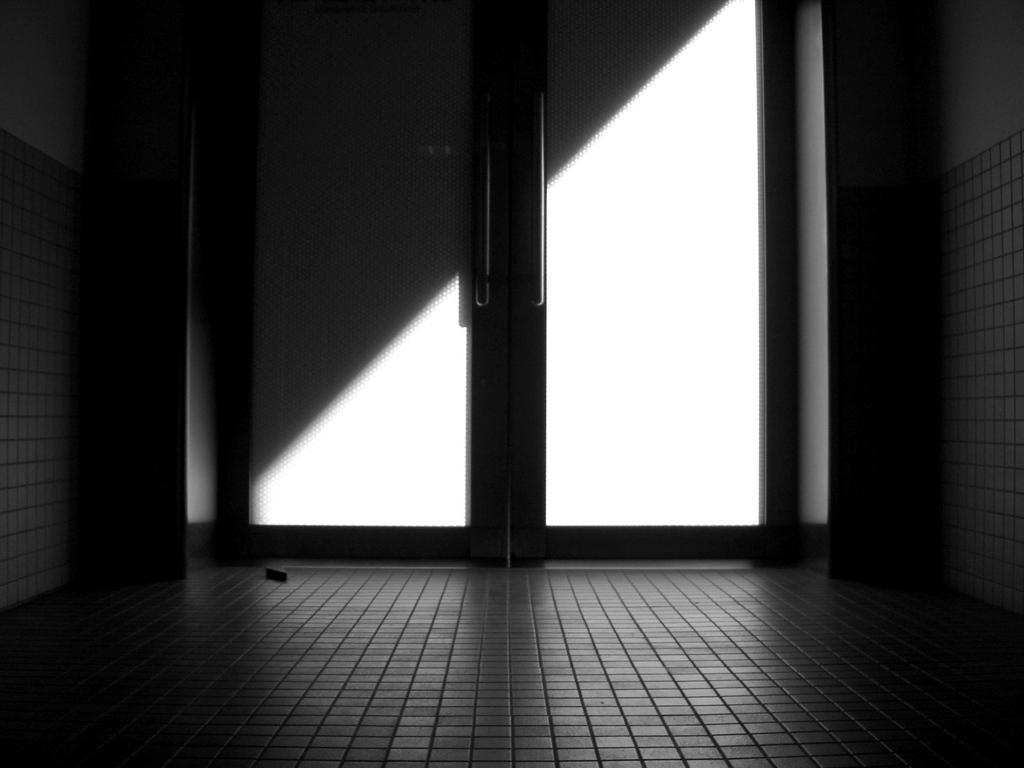Could you give a brief overview of what you see in this image? This is a black and white picture. In this picture we can see a door. On either side of the door we can see the walls. At the bottom portion of the picture we can see the floor. 